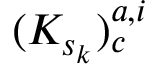<formula> <loc_0><loc_0><loc_500><loc_500>( K _ { s _ { k } } ) _ { c } ^ { a , i }</formula> 